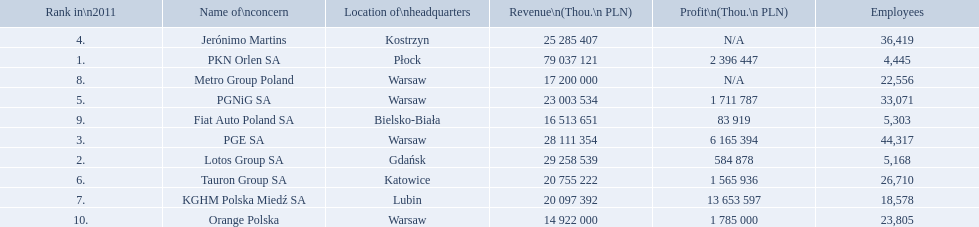What company has 28 111 354 thou.in revenue? PGE SA. What revenue does lotus group sa have? 29 258 539. Who has the next highest revenue than lotus group sa? PKN Orlen SA. 